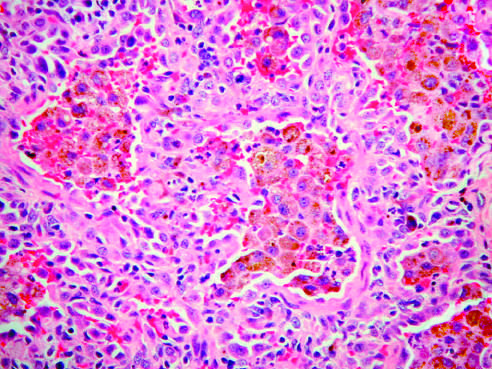does lung biopsy specimen demonstrate large numbers of intraalveolar hemosiderin-laden macrophages on a background of thickened fibrous septa?
Answer the question using a single word or phrase. Yes 